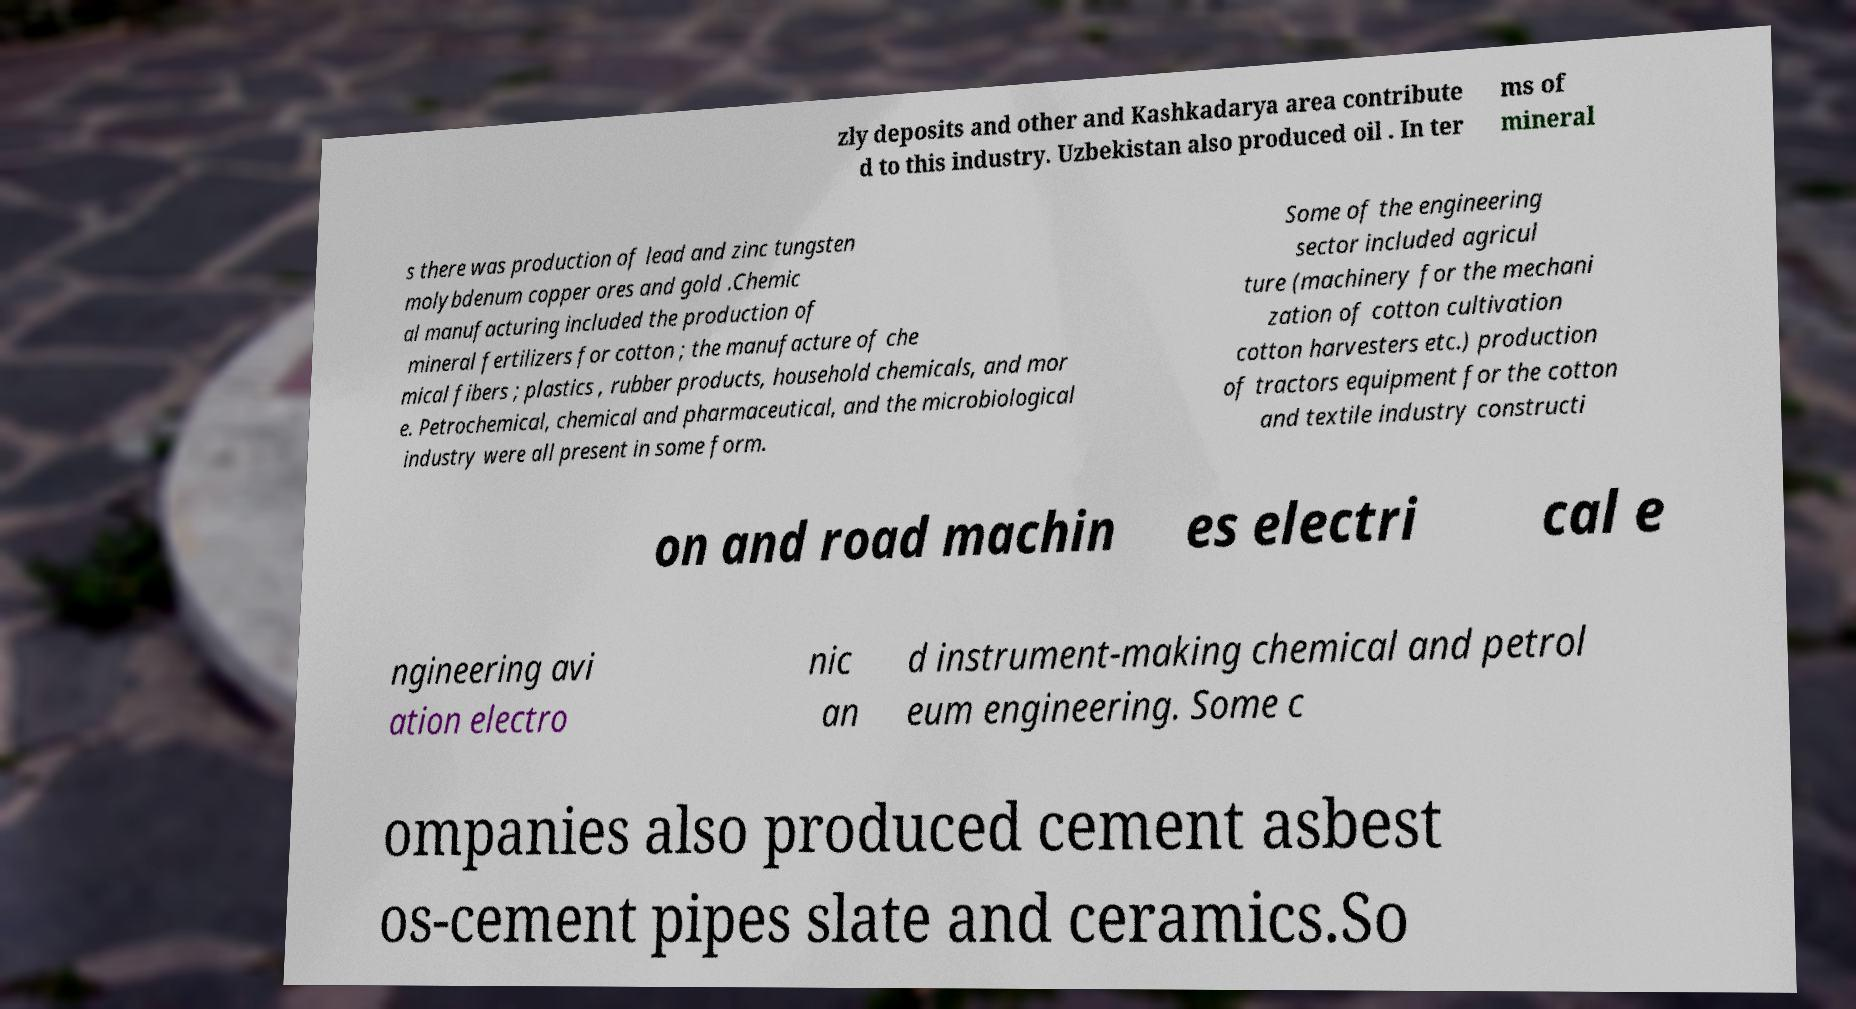Please read and relay the text visible in this image. What does it say? zly deposits and other and Kashkadarya area contribute d to this industry. Uzbekistan also produced oil . In ter ms of mineral s there was production of lead and zinc tungsten molybdenum copper ores and gold .Chemic al manufacturing included the production of mineral fertilizers for cotton ; the manufacture of che mical fibers ; plastics , rubber products, household chemicals, and mor e. Petrochemical, chemical and pharmaceutical, and the microbiological industry were all present in some form. Some of the engineering sector included agricul ture (machinery for the mechani zation of cotton cultivation cotton harvesters etc.) production of tractors equipment for the cotton and textile industry constructi on and road machin es electri cal e ngineering avi ation electro nic an d instrument-making chemical and petrol eum engineering. Some c ompanies also produced cement asbest os-cement pipes slate and ceramics.So 